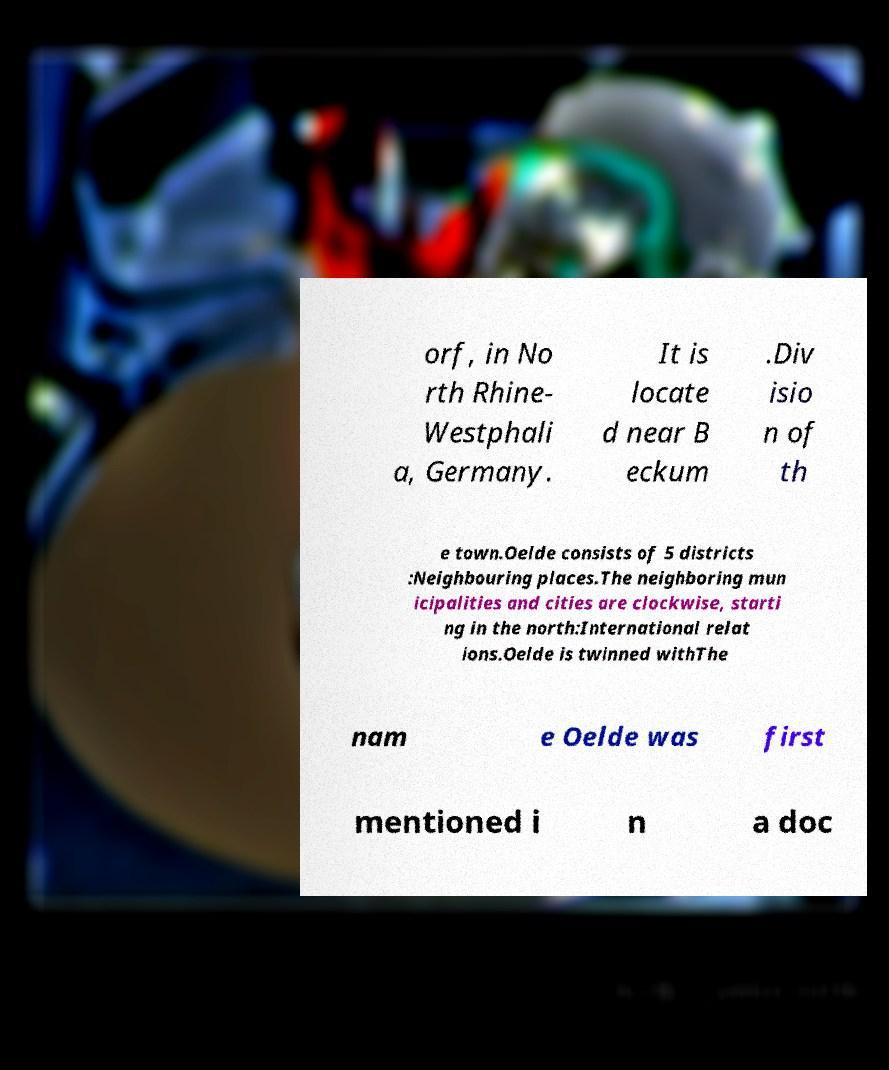Please identify and transcribe the text found in this image. orf, in No rth Rhine- Westphali a, Germany. It is locate d near B eckum .Div isio n of th e town.Oelde consists of 5 districts :Neighbouring places.The neighboring mun icipalities and cities are clockwise, starti ng in the north:International relat ions.Oelde is twinned withThe nam e Oelde was first mentioned i n a doc 